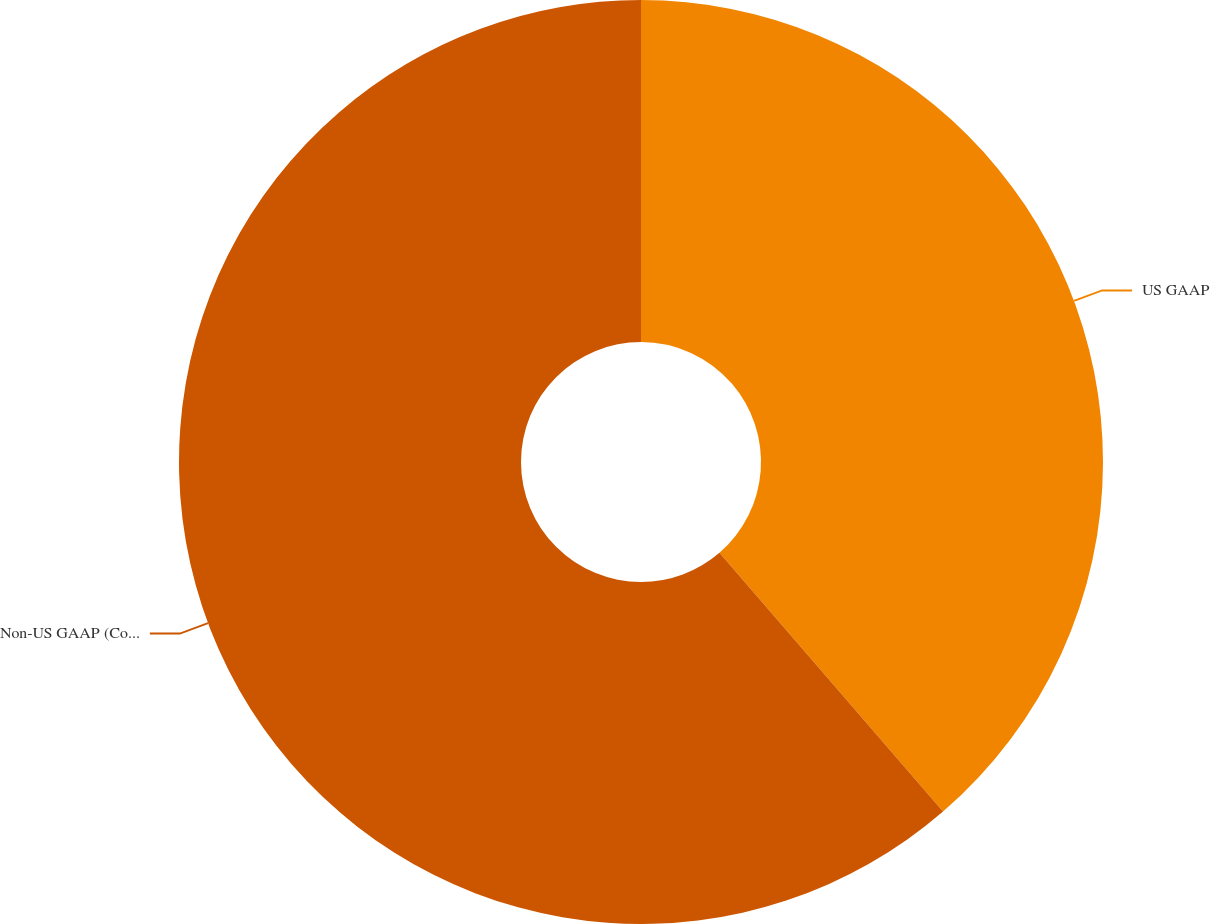Convert chart to OTSL. <chart><loc_0><loc_0><loc_500><loc_500><pie_chart><fcel>US GAAP<fcel>Non-US GAAP (Core Taxes)<nl><fcel>38.66%<fcel>61.34%<nl></chart> 